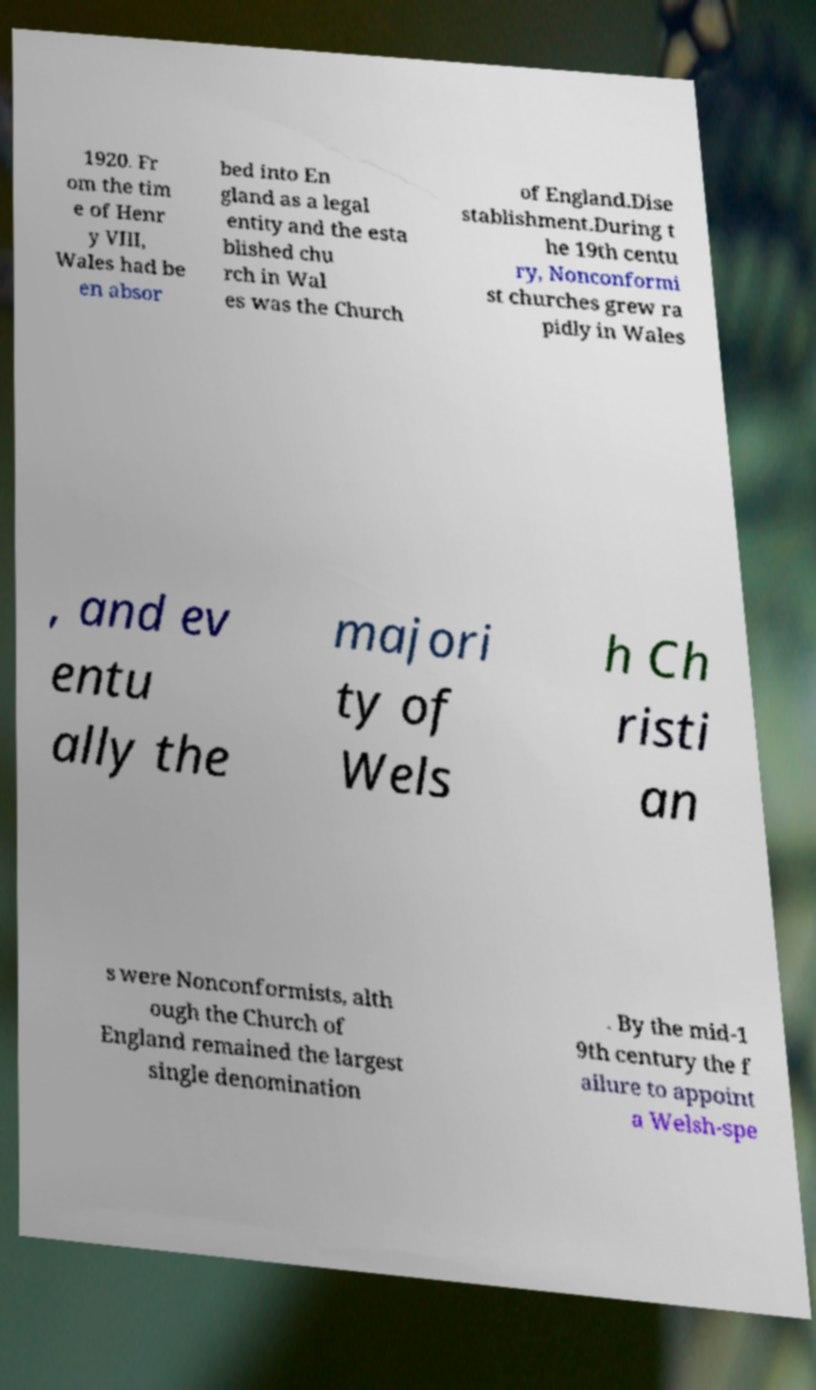Could you assist in decoding the text presented in this image and type it out clearly? 1920. Fr om the tim e of Henr y VIII, Wales had be en absor bed into En gland as a legal entity and the esta blished chu rch in Wal es was the Church of England.Dise stablishment.During t he 19th centu ry, Nonconformi st churches grew ra pidly in Wales , and ev entu ally the majori ty of Wels h Ch risti an s were Nonconformists, alth ough the Church of England remained the largest single denomination . By the mid-1 9th century the f ailure to appoint a Welsh-spe 